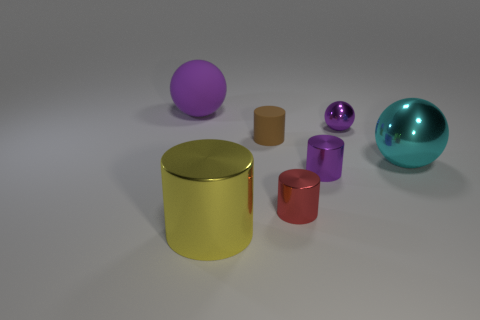What material is the large object behind the shiny sphere that is in front of the small brown rubber cylinder?
Provide a succinct answer. Rubber. There is a yellow metal object that is the same shape as the brown thing; what size is it?
Give a very brief answer. Large. Do the big matte thing and the tiny ball have the same color?
Ensure brevity in your answer.  Yes. The thing that is right of the small rubber thing and behind the large cyan metal object is what color?
Provide a short and direct response. Purple. There is a metal sphere to the right of the purple shiny sphere; is it the same size as the yellow cylinder?
Make the answer very short. Yes. Do the large yellow cylinder and the big purple ball that is on the left side of the big cyan object have the same material?
Provide a succinct answer. No. What number of brown things are either big rubber cylinders or small matte objects?
Make the answer very short. 1. Are any blue rubber cylinders visible?
Make the answer very short. No. There is a big ball in front of the ball to the left of the yellow thing; is there a yellow cylinder in front of it?
Offer a very short reply. Yes. There is a small matte object; is it the same shape as the metal thing behind the matte cylinder?
Give a very brief answer. No. 